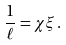Convert formula to latex. <formula><loc_0><loc_0><loc_500><loc_500>\frac { 1 } { \ell } = \chi \xi \, .</formula> 